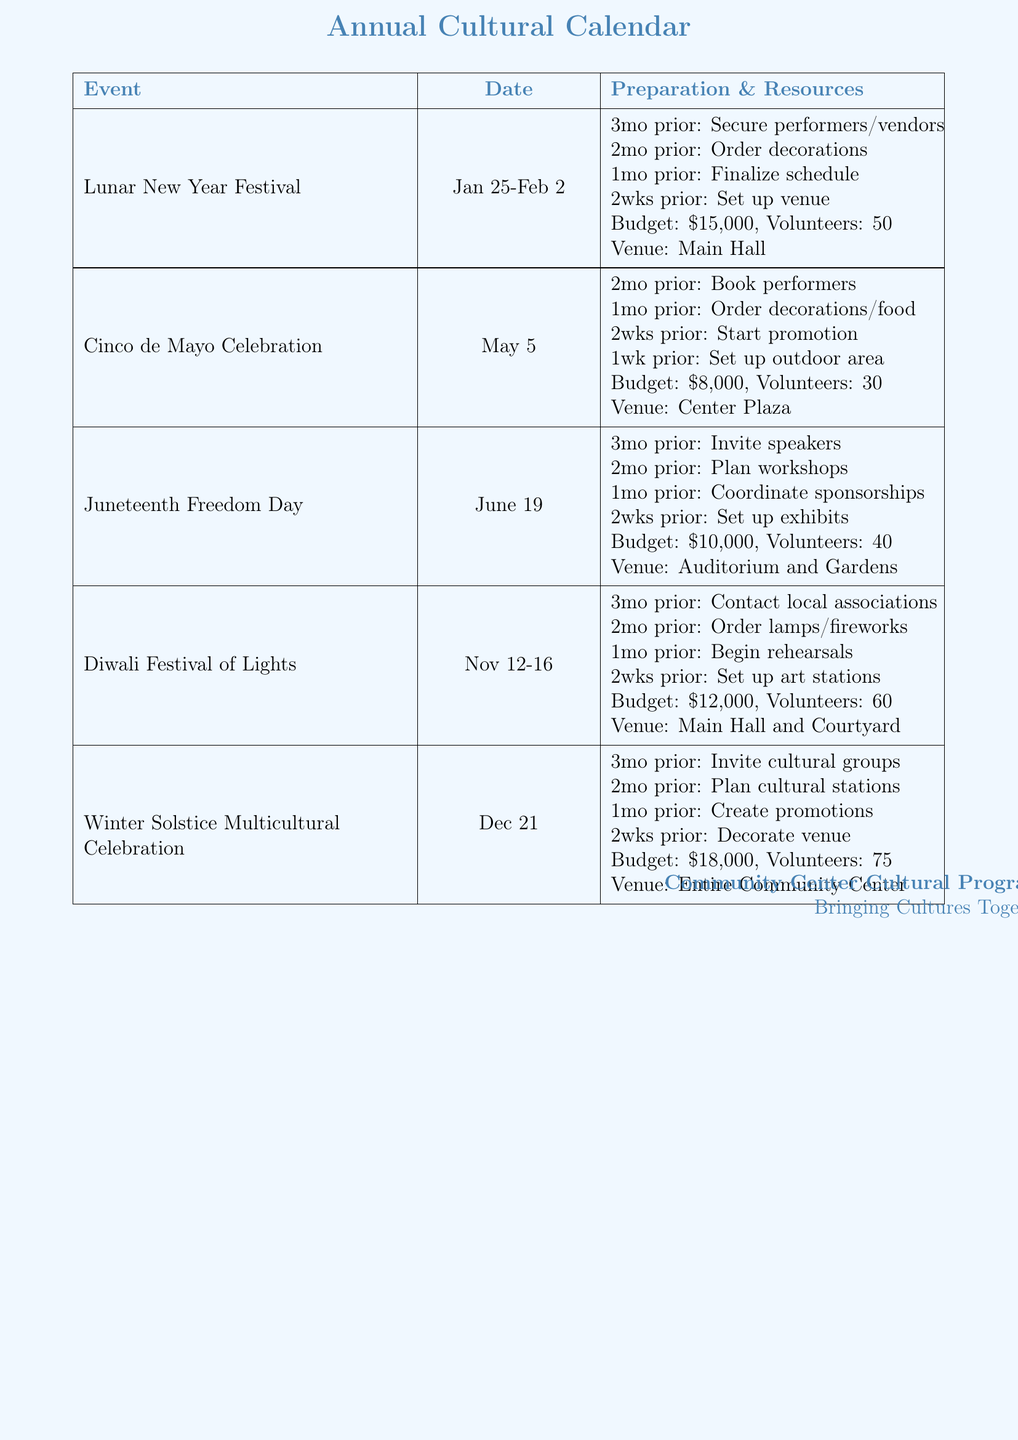What is the date of the Lunar New Year Festival? The date for the Lunar New Year Festival is provided in the document, which is January 25 to February 2.
Answer: January 25-February 2 How many volunteers are needed for the Winter Solstice Celebration? The document specifies the number of volunteers required for each event, stating that 75 volunteers are needed for the Winter Solstice Multicultural Celebration.
Answer: 75 What equipment is required for the Diwali Festival of Lights? The document lists the equipment needed for the Diwali Festival of Lights, which includes lighting equipment, dance floor, and sound system.
Answer: Lighting equipment, dance floor, sound system What is the budget for the Cinco de Mayo Celebration? The document indicates the budget allocated for the Cinco de Mayo Celebration, which is $8,000.
Answer: $8,000 What preparation task needs to be done three months prior to the Juneteenth Freedom Day? The document outlines the preparation timeline, stating that the task to invite guest speakers and local leaders should be completed three months prior to Juneteenth Freedom Day.
Answer: Invite guest speakers and local leaders Which venue will host the Lunar New Year Festival? The document specifies the venue for the Lunar New Year Festival as the Community Center Main Hall.
Answer: Community Center Main Hall How long does the Diwali Festival of Lights last? The document provides the date range for the Diwali Festival of Lights, indicating it lasts five days.
Answer: November 12-16 What type of stage is needed for the Cinco de Mayo Celebration? The document mentions the equipment required, which includes an outdoor stage for the Cinco de Mayo Celebration.
Answer: Outdoor stage 